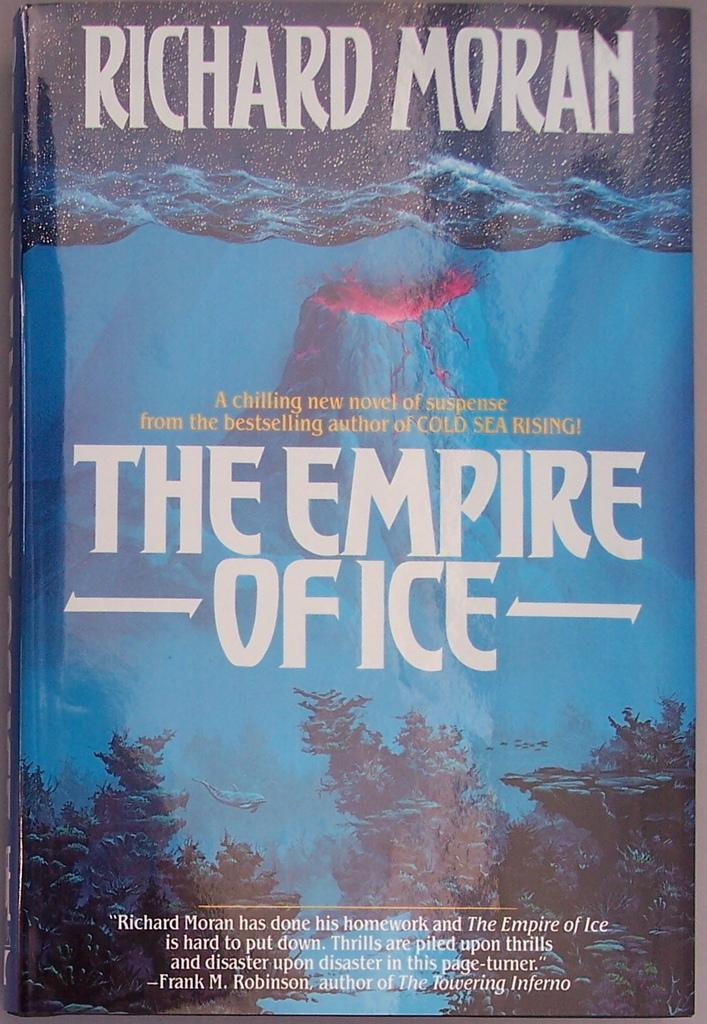Provide a one-sentence caption for the provided image. A book called The Empire of Ice has a volcano on the cover. 